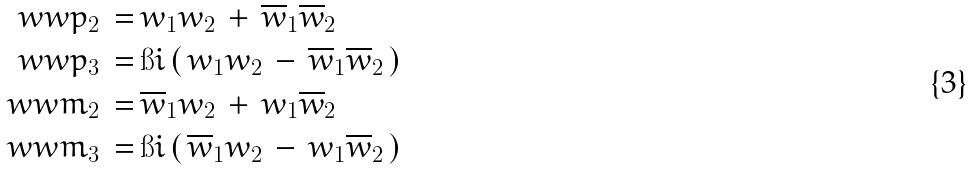<formula> <loc_0><loc_0><loc_500><loc_500>\ w w p _ { 2 } \, = \, & w _ { 1 } w _ { 2 } \, + \, \overline { w } _ { 1 } \overline { w } _ { 2 } \\ \ w w p _ { 3 } \, = \, & \i i \, ( \, w _ { 1 } w _ { 2 } \, - \, \overline { w } _ { 1 } \overline { w } _ { 2 } \, ) \\ \ w w m _ { 2 } \, = \, & \overline { w } _ { 1 } w _ { 2 } \, + \, w _ { 1 } \overline { w } _ { 2 } \\ \ w w m _ { 3 } \, = \, & \i i \, ( \, \overline { w } _ { 1 } w _ { 2 } \, - \, w _ { 1 } \overline { w } _ { 2 } \, )</formula> 